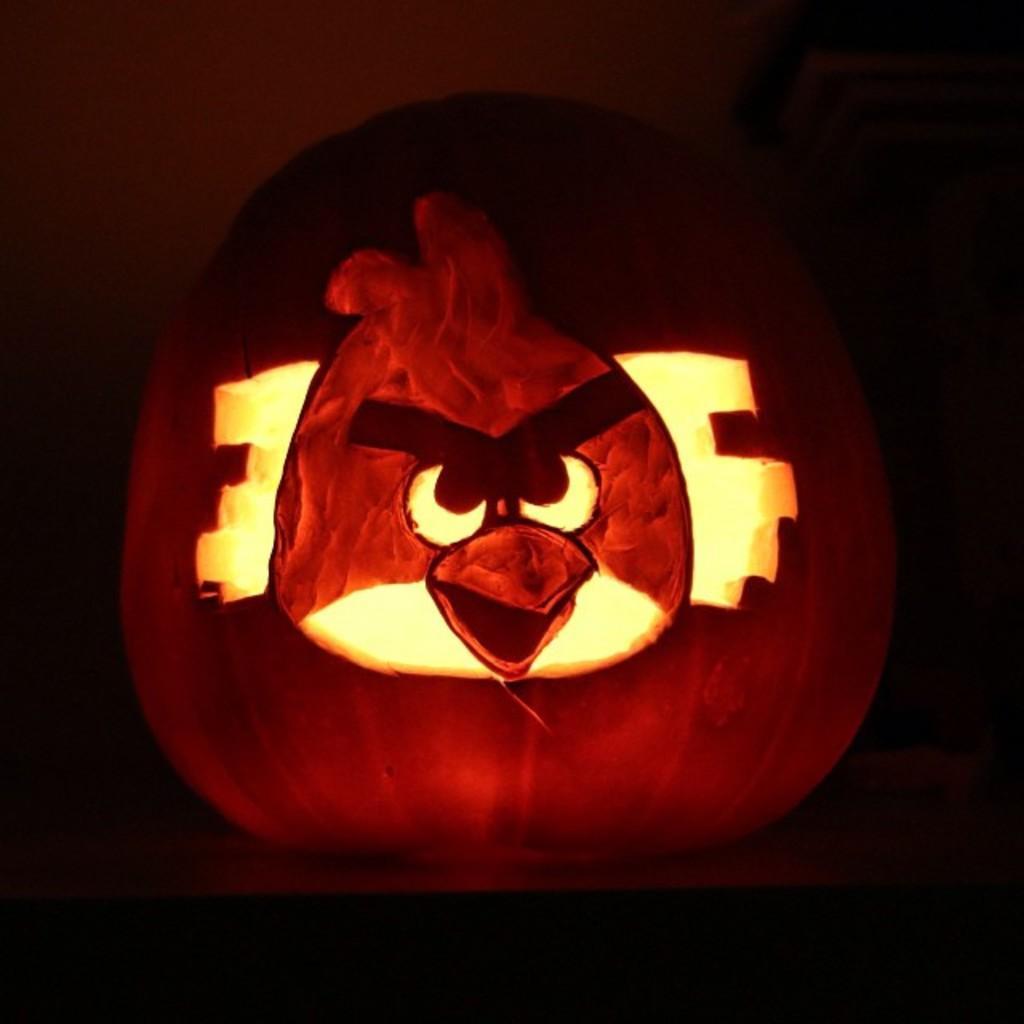In one or two sentences, can you explain what this image depicts? This picture looks like a pumpkin and I can see dark background. 